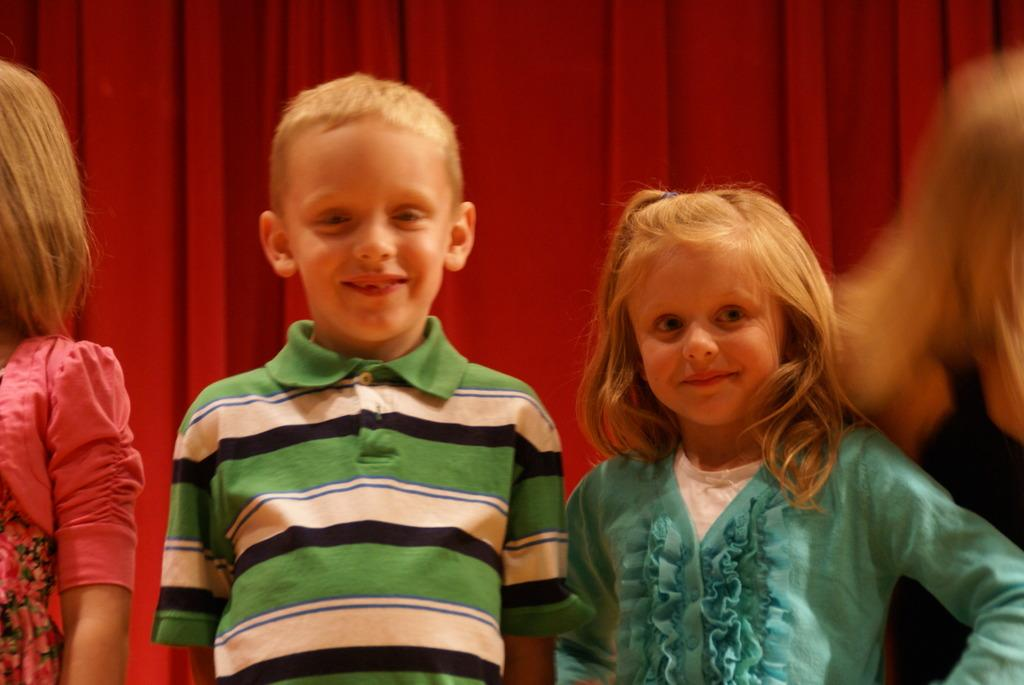What is the main subject of the image? The main subject of the image is children standing in the center. Can you describe the background of the image? There is a curtain visible in the background of the image. What time of day is it in the image? There is no mention of time or time of day in the image, so it cannot be determined. 